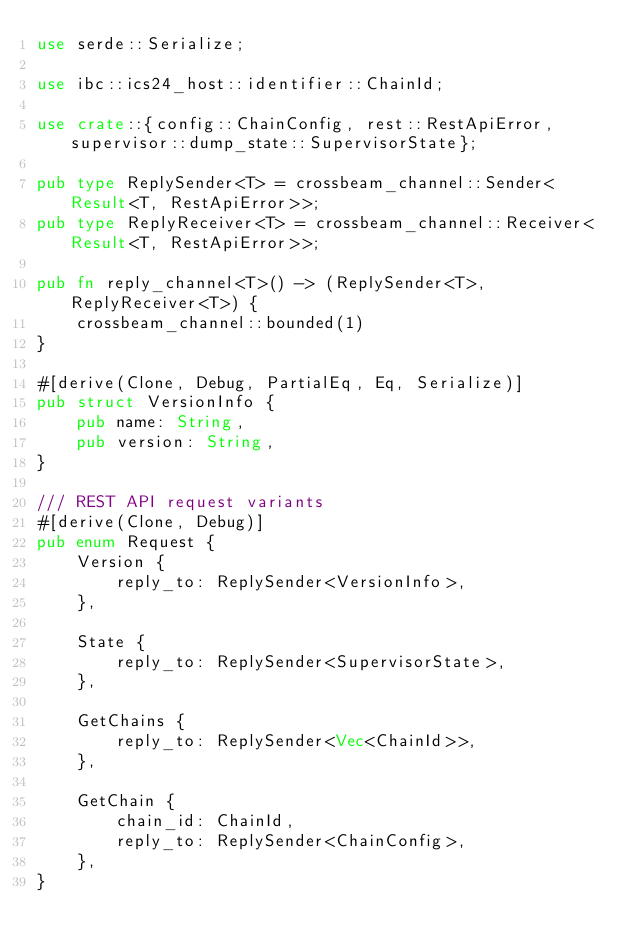Convert code to text. <code><loc_0><loc_0><loc_500><loc_500><_Rust_>use serde::Serialize;

use ibc::ics24_host::identifier::ChainId;

use crate::{config::ChainConfig, rest::RestApiError, supervisor::dump_state::SupervisorState};

pub type ReplySender<T> = crossbeam_channel::Sender<Result<T, RestApiError>>;
pub type ReplyReceiver<T> = crossbeam_channel::Receiver<Result<T, RestApiError>>;

pub fn reply_channel<T>() -> (ReplySender<T>, ReplyReceiver<T>) {
    crossbeam_channel::bounded(1)
}

#[derive(Clone, Debug, PartialEq, Eq, Serialize)]
pub struct VersionInfo {
    pub name: String,
    pub version: String,
}

/// REST API request variants
#[derive(Clone, Debug)]
pub enum Request {
    Version {
        reply_to: ReplySender<VersionInfo>,
    },

    State {
        reply_to: ReplySender<SupervisorState>,
    },

    GetChains {
        reply_to: ReplySender<Vec<ChainId>>,
    },

    GetChain {
        chain_id: ChainId,
        reply_to: ReplySender<ChainConfig>,
    },
}
</code> 